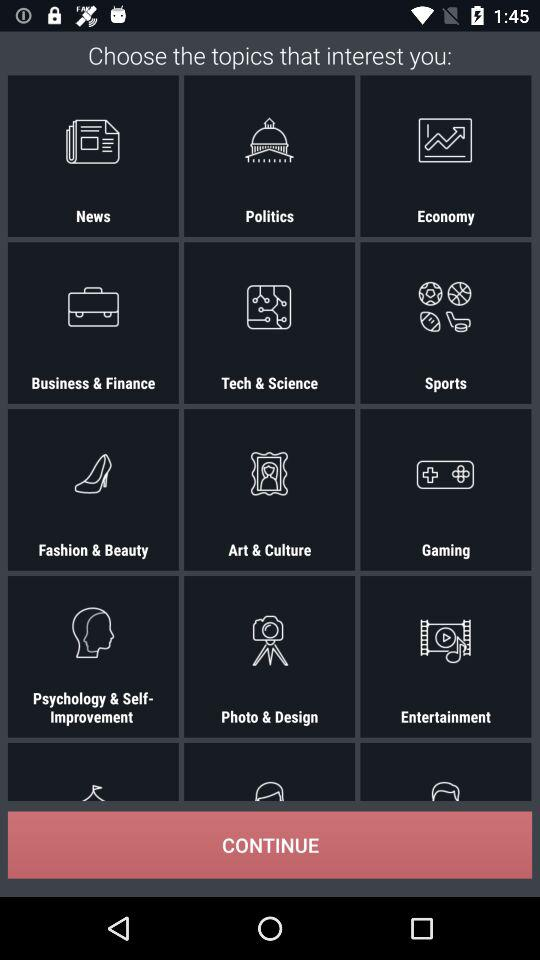What are the names of the different topics shown on the screen? The names of the different topics are "News", "Politics", "Economy, Business & Finance", "Tech & Science", "Sports", "Fashion & Beauty", "Art & Culture", "Gaming", "Psychology & Self-Improvement", "Photo&Design" and "Entertainment". 